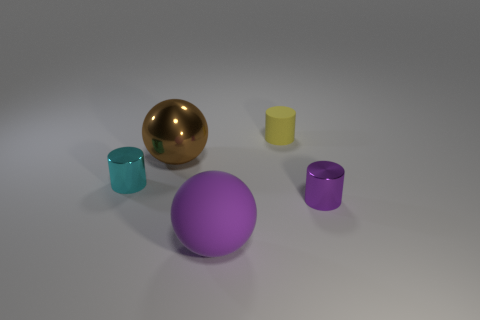Add 1 large cyan things. How many objects exist? 6 Subtract all cylinders. How many objects are left? 2 Add 3 balls. How many balls exist? 5 Subtract 1 yellow cylinders. How many objects are left? 4 Subtract all small cylinders. Subtract all big brown spheres. How many objects are left? 1 Add 1 brown things. How many brown things are left? 2 